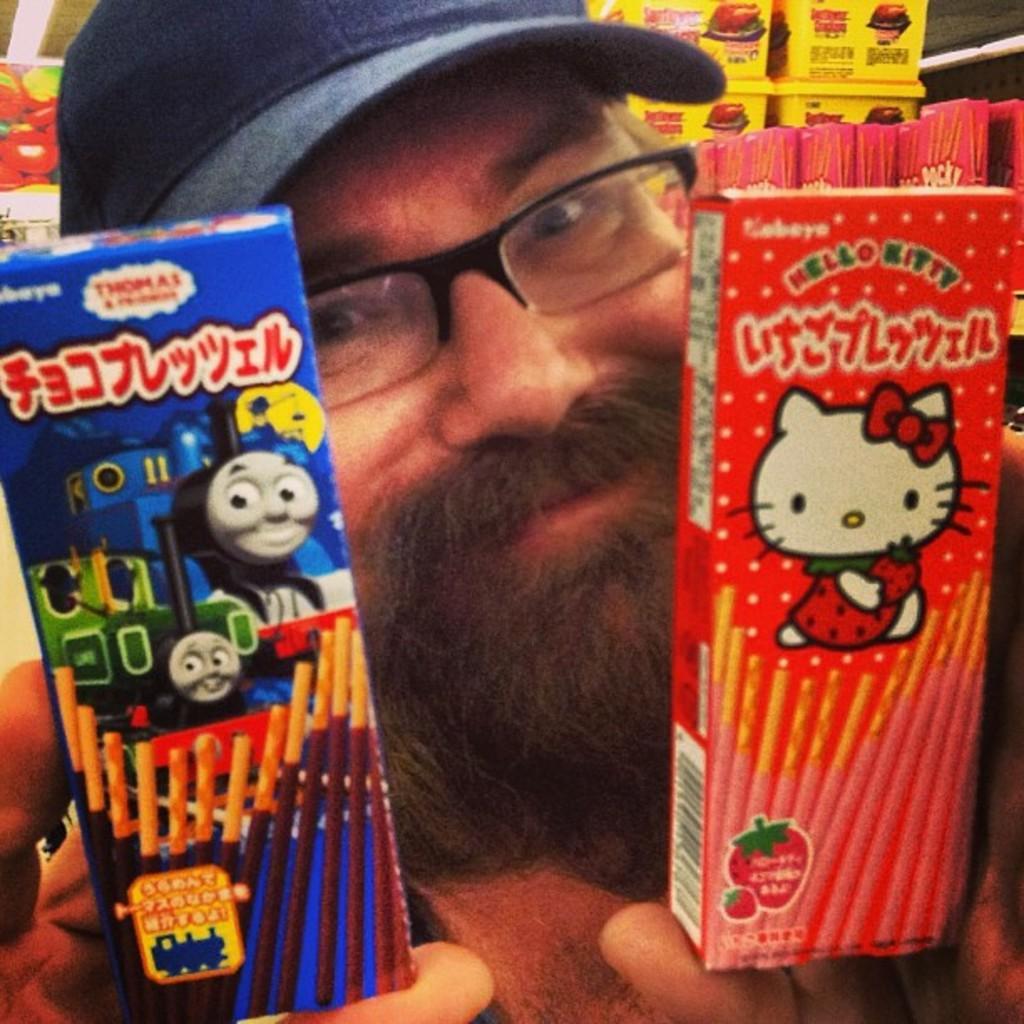In one or two sentences, can you explain what this image depicts? In this image in the foreground there is one person who is holding some packets, and in the background there are some boxes and objects. 